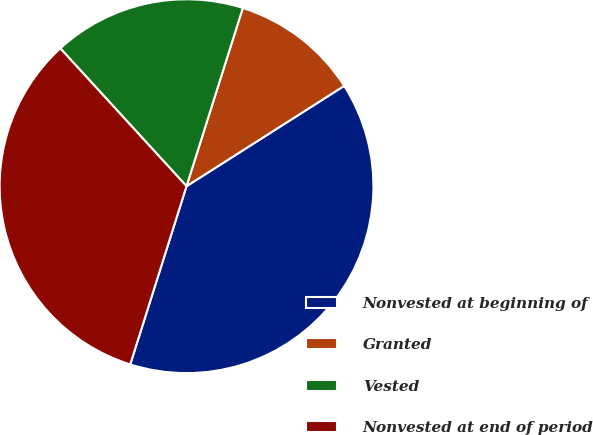Convert chart. <chart><loc_0><loc_0><loc_500><loc_500><pie_chart><fcel>Nonvested at beginning of<fcel>Granted<fcel>Vested<fcel>Nonvested at end of period<nl><fcel>38.89%<fcel>11.11%<fcel>16.67%<fcel>33.33%<nl></chart> 